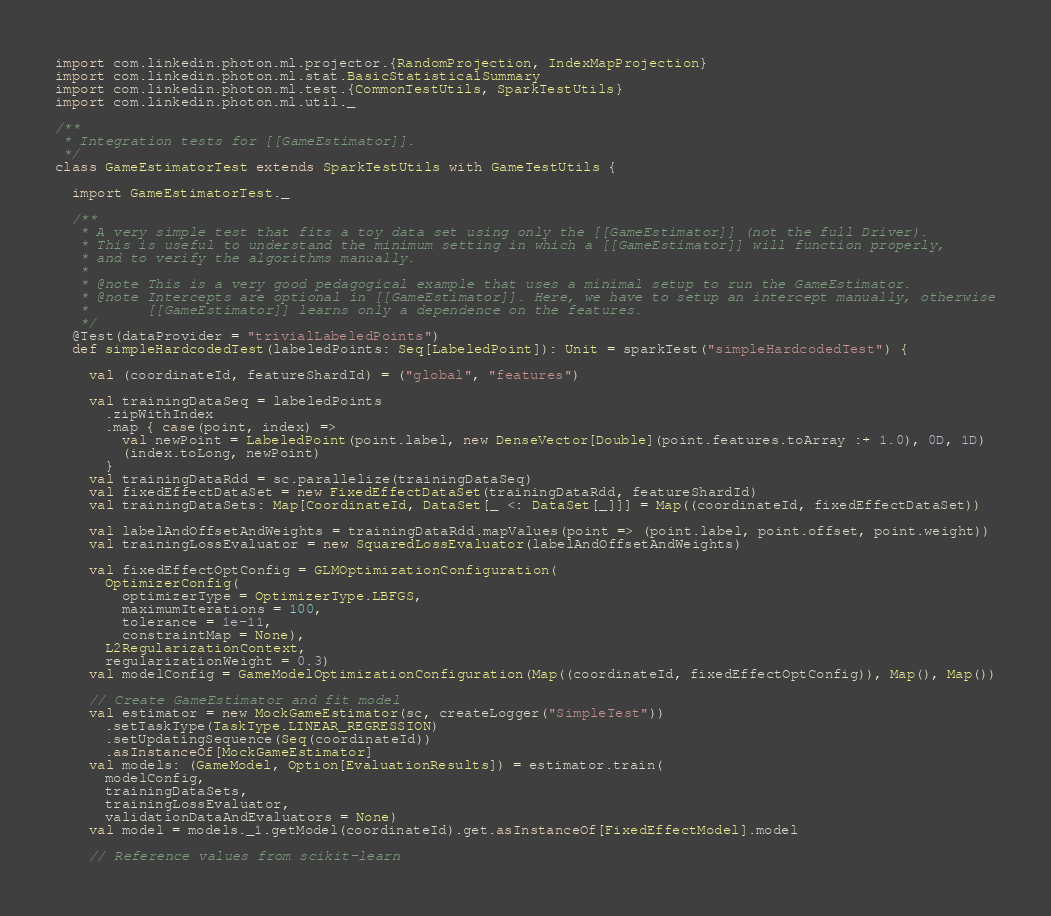<code> <loc_0><loc_0><loc_500><loc_500><_Scala_>import com.linkedin.photon.ml.projector.{RandomProjection, IndexMapProjection}
import com.linkedin.photon.ml.stat.BasicStatisticalSummary
import com.linkedin.photon.ml.test.{CommonTestUtils, SparkTestUtils}
import com.linkedin.photon.ml.util._

/**
 * Integration tests for [[GameEstimator]].
 */
class GameEstimatorTest extends SparkTestUtils with GameTestUtils {

  import GameEstimatorTest._

  /**
   * A very simple test that fits a toy data set using only the [[GameEstimator]] (not the full Driver).
   * This is useful to understand the minimum setting in which a [[GameEstimator]] will function properly,
   * and to verify the algorithms manually.
   *
   * @note This is a very good pedagogical example that uses a minimal setup to run the GameEstimator.
   * @note Intercepts are optional in [[GameEstimator]]. Here, we have to setup an intercept manually, otherwise
   *       [[GameEstimator]] learns only a dependence on the features.
   */
  @Test(dataProvider = "trivialLabeledPoints")
  def simpleHardcodedTest(labeledPoints: Seq[LabeledPoint]): Unit = sparkTest("simpleHardcodedTest") {

    val (coordinateId, featureShardId) = ("global", "features")

    val trainingDataSeq = labeledPoints
      .zipWithIndex
      .map { case(point, index) =>
        val newPoint = LabeledPoint(point.label, new DenseVector[Double](point.features.toArray :+ 1.0), 0D, 1D)
        (index.toLong, newPoint)
      }
    val trainingDataRdd = sc.parallelize(trainingDataSeq)
    val fixedEffectDataSet = new FixedEffectDataSet(trainingDataRdd, featureShardId)
    val trainingDataSets: Map[CoordinateId, DataSet[_ <: DataSet[_]]] = Map((coordinateId, fixedEffectDataSet))

    val labelAndOffsetAndWeights = trainingDataRdd.mapValues(point => (point.label, point.offset, point.weight))
    val trainingLossEvaluator = new SquaredLossEvaluator(labelAndOffsetAndWeights)

    val fixedEffectOptConfig = GLMOptimizationConfiguration(
      OptimizerConfig(
        optimizerType = OptimizerType.LBFGS,
        maximumIterations = 100,
        tolerance = 1e-11,
        constraintMap = None),
      L2RegularizationContext,
      regularizationWeight = 0.3)
    val modelConfig = GameModelOptimizationConfiguration(Map((coordinateId, fixedEffectOptConfig)), Map(), Map())

    // Create GameEstimator and fit model
    val estimator = new MockGameEstimator(sc, createLogger("SimpleTest"))
      .setTaskType(TaskType.LINEAR_REGRESSION)
      .setUpdatingSequence(Seq(coordinateId))
      .asInstanceOf[MockGameEstimator]
    val models: (GameModel, Option[EvaluationResults]) = estimator.train(
      modelConfig,
      trainingDataSets,
      trainingLossEvaluator,
      validationDataAndEvaluators = None)
    val model = models._1.getModel(coordinateId).get.asInstanceOf[FixedEffectModel].model

    // Reference values from scikit-learn</code> 